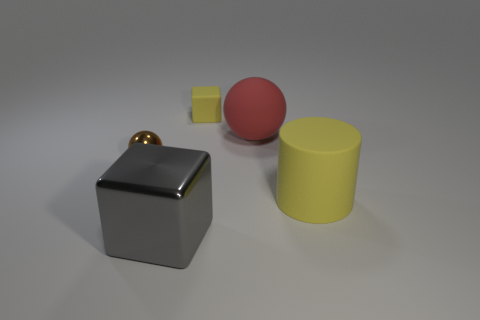The object that is the same color as the big cylinder is what shape?
Make the answer very short. Cube. Are the block that is behind the small brown metal object and the ball that is behind the small shiny ball made of the same material?
Offer a terse response. Yes. Is there any other thing that is the same shape as the red thing?
Your answer should be very brief. Yes. What color is the large block?
Your response must be concise. Gray. How many big red matte objects are the same shape as the brown object?
Provide a succinct answer. 1. There is another rubber thing that is the same size as the red matte thing; what color is it?
Your answer should be compact. Yellow. Is there a red metallic cylinder?
Give a very brief answer. No. The yellow rubber thing that is behind the cylinder has what shape?
Your answer should be compact. Cube. What number of yellow rubber objects are right of the red sphere and behind the large yellow object?
Provide a succinct answer. 0. Is there another tiny cube that has the same material as the small yellow block?
Provide a short and direct response. No. 